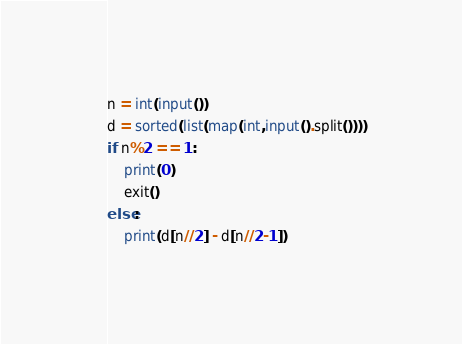<code> <loc_0><loc_0><loc_500><loc_500><_Python_>n = int(input())
d = sorted(list(map(int,input().split())))
if n%2 == 1:
    print(0)
    exit()
else:
    print(d[n//2] - d[n//2-1])
</code> 